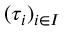<formula> <loc_0><loc_0><loc_500><loc_500>( \tau _ { i } ) _ { i \in I }</formula> 